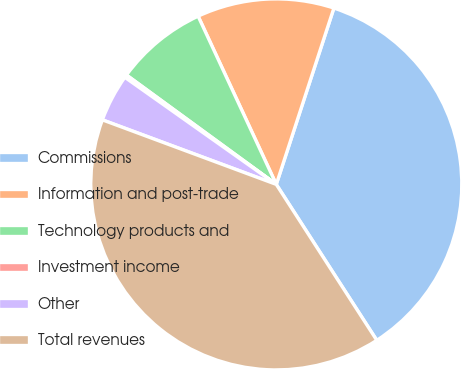<chart> <loc_0><loc_0><loc_500><loc_500><pie_chart><fcel>Commissions<fcel>Information and post-trade<fcel>Technology products and<fcel>Investment income<fcel>Other<fcel>Total revenues<nl><fcel>35.86%<fcel>11.95%<fcel>8.04%<fcel>0.24%<fcel>4.14%<fcel>39.77%<nl></chart> 